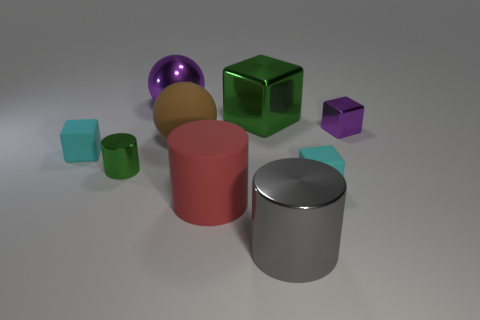Is there a thing of the same color as the small shiny cylinder?
Offer a very short reply. Yes. What number of things are either small cyan objects on the right side of the small cylinder or green metal things?
Give a very brief answer. 3. What number of other objects are the same material as the big green block?
Give a very brief answer. 4. What is the shape of the thing that is the same color as the big cube?
Offer a very short reply. Cylinder. How big is the metal cylinder that is in front of the red thing?
Give a very brief answer. Large. There is a tiny object that is the same material as the small cylinder; what is its shape?
Keep it short and to the point. Cube. Does the big gray cylinder have the same material as the cylinder left of the brown matte ball?
Give a very brief answer. Yes. Do the cyan rubber object right of the big gray shiny cylinder and the small purple shiny object have the same shape?
Make the answer very short. Yes. There is a large red object that is the same shape as the big gray thing; what is its material?
Make the answer very short. Rubber. Does the red matte thing have the same shape as the purple thing that is to the right of the big red rubber cylinder?
Your response must be concise. No. 